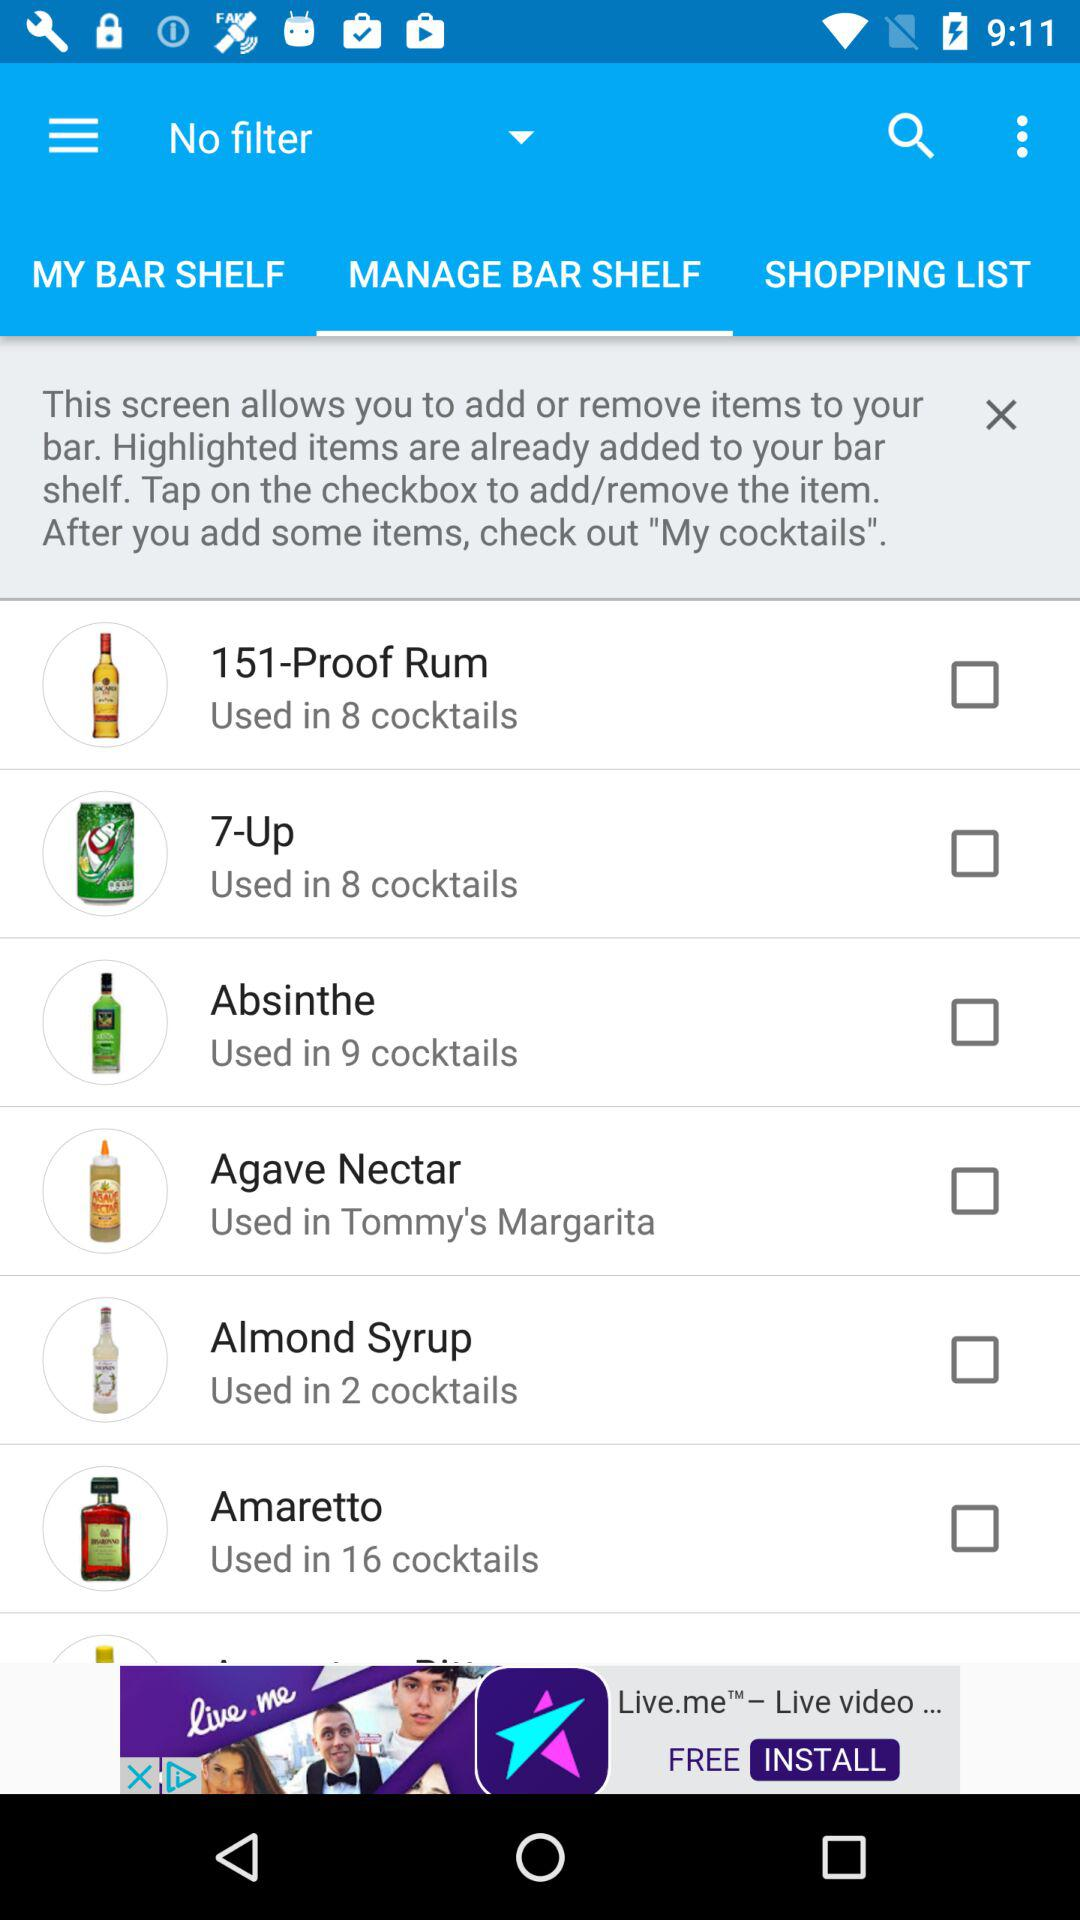How many cocktails use the ingredient '7-Up'?
Answer the question using a single word or phrase. 8 